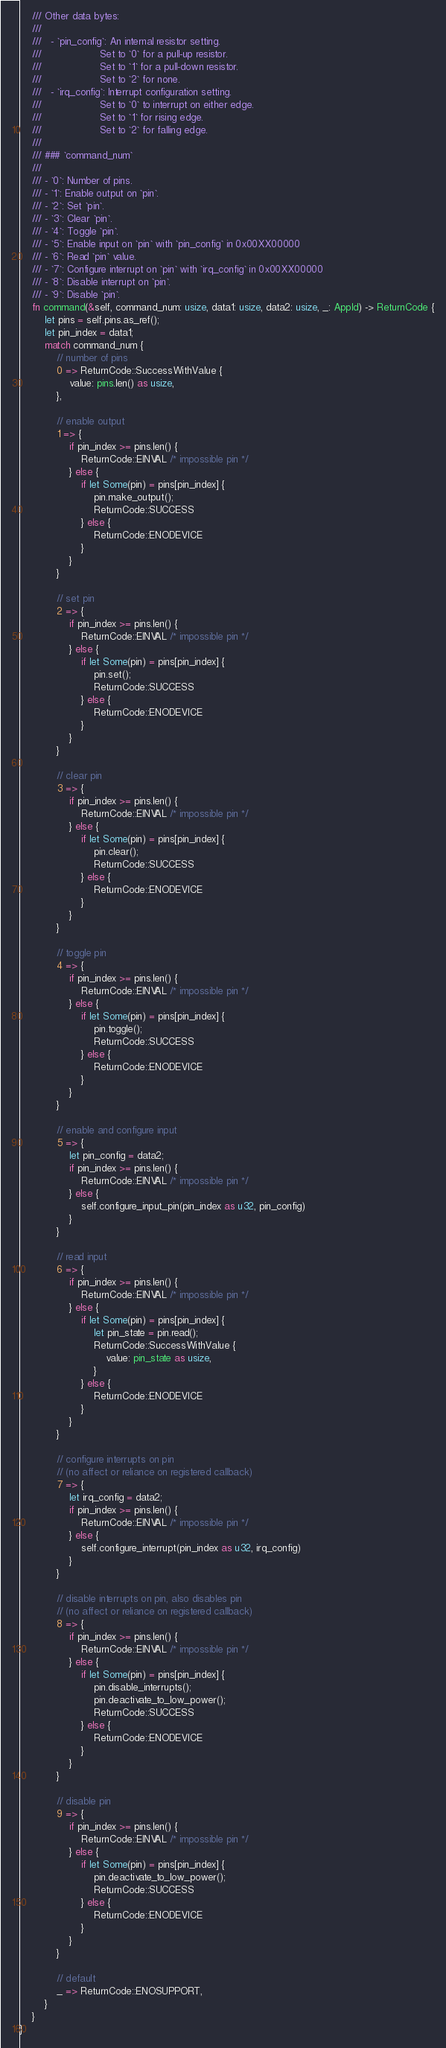<code> <loc_0><loc_0><loc_500><loc_500><_Rust_>    /// Other data bytes:
    ///
    ///   - `pin_config`: An internal resistor setting.
    ///                   Set to `0` for a pull-up resistor.
    ///                   Set to `1` for a pull-down resistor.
    ///                   Set to `2` for none.
    ///   - `irq_config`: Interrupt configuration setting.
    ///                   Set to `0` to interrupt on either edge.
    ///                   Set to `1` for rising edge.
    ///                   Set to `2` for falling edge.
    ///
    /// ### `command_num`
    ///
    /// - `0`: Number of pins.
    /// - `1`: Enable output on `pin`.
    /// - `2`: Set `pin`.
    /// - `3`: Clear `pin`.
    /// - `4`: Toggle `pin`.
    /// - `5`: Enable input on `pin` with `pin_config` in 0x00XX00000
    /// - `6`: Read `pin` value.
    /// - `7`: Configure interrupt on `pin` with `irq_config` in 0x00XX00000
    /// - `8`: Disable interrupt on `pin`.
    /// - `9`: Disable `pin`.
    fn command(&self, command_num: usize, data1: usize, data2: usize, _: AppId) -> ReturnCode {
        let pins = self.pins.as_ref();
        let pin_index = data1;
        match command_num {
            // number of pins
            0 => ReturnCode::SuccessWithValue {
                value: pins.len() as usize,
            },

            // enable output
            1 => {
                if pin_index >= pins.len() {
                    ReturnCode::EINVAL /* impossible pin */
                } else {
                    if let Some(pin) = pins[pin_index] {
                        pin.make_output();
                        ReturnCode::SUCCESS
                    } else {
                        ReturnCode::ENODEVICE
                    }
                }
            }

            // set pin
            2 => {
                if pin_index >= pins.len() {
                    ReturnCode::EINVAL /* impossible pin */
                } else {
                    if let Some(pin) = pins[pin_index] {
                        pin.set();
                        ReturnCode::SUCCESS
                    } else {
                        ReturnCode::ENODEVICE
                    }
                }
            }

            // clear pin
            3 => {
                if pin_index >= pins.len() {
                    ReturnCode::EINVAL /* impossible pin */
                } else {
                    if let Some(pin) = pins[pin_index] {
                        pin.clear();
                        ReturnCode::SUCCESS
                    } else {
                        ReturnCode::ENODEVICE
                    }
                }
            }

            // toggle pin
            4 => {
                if pin_index >= pins.len() {
                    ReturnCode::EINVAL /* impossible pin */
                } else {
                    if let Some(pin) = pins[pin_index] {
                        pin.toggle();
                        ReturnCode::SUCCESS
                    } else {
                        ReturnCode::ENODEVICE
                    }
                }
            }

            // enable and configure input
            5 => {
                let pin_config = data2;
                if pin_index >= pins.len() {
                    ReturnCode::EINVAL /* impossible pin */
                } else {
                    self.configure_input_pin(pin_index as u32, pin_config)
                }
            }

            // read input
            6 => {
                if pin_index >= pins.len() {
                    ReturnCode::EINVAL /* impossible pin */
                } else {
                    if let Some(pin) = pins[pin_index] {
                        let pin_state = pin.read();
                        ReturnCode::SuccessWithValue {
                            value: pin_state as usize,
                        }
                    } else {
                        ReturnCode::ENODEVICE
                    }
                }
            }

            // configure interrupts on pin
            // (no affect or reliance on registered callback)
            7 => {
                let irq_config = data2;
                if pin_index >= pins.len() {
                    ReturnCode::EINVAL /* impossible pin */
                } else {
                    self.configure_interrupt(pin_index as u32, irq_config)
                }
            }

            // disable interrupts on pin, also disables pin
            // (no affect or reliance on registered callback)
            8 => {
                if pin_index >= pins.len() {
                    ReturnCode::EINVAL /* impossible pin */
                } else {
                    if let Some(pin) = pins[pin_index] {
                        pin.disable_interrupts();
                        pin.deactivate_to_low_power();
                        ReturnCode::SUCCESS
                    } else {
                        ReturnCode::ENODEVICE
                    }
                }
            }

            // disable pin
            9 => {
                if pin_index >= pins.len() {
                    ReturnCode::EINVAL /* impossible pin */
                } else {
                    if let Some(pin) = pins[pin_index] {
                        pin.deactivate_to_low_power();
                        ReturnCode::SUCCESS
                    } else {
                        ReturnCode::ENODEVICE
                    }
                }
            }

            // default
            _ => ReturnCode::ENOSUPPORT,
        }
    }
}
</code> 